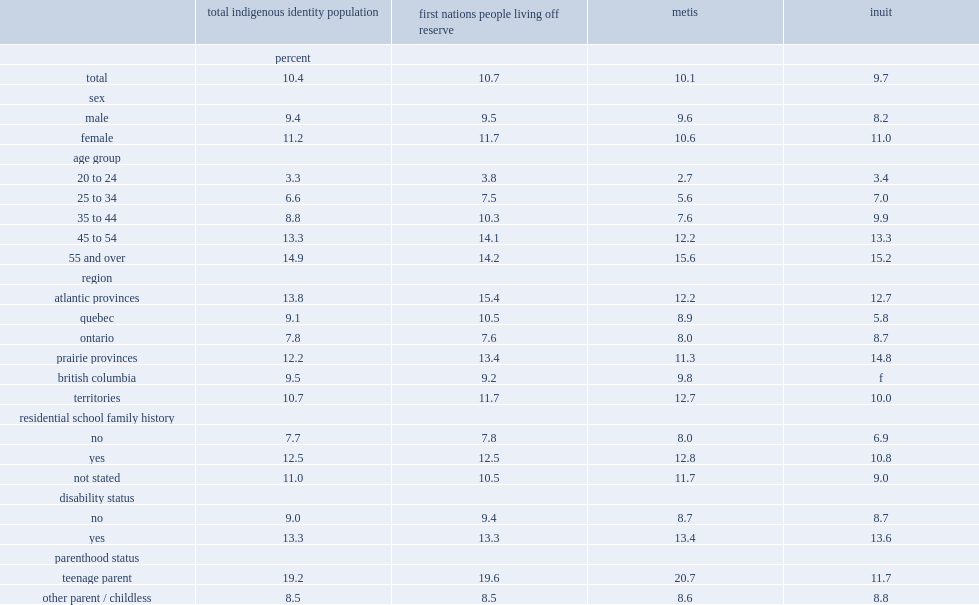How many percent of indigenous adults aged 20 to 24 reported completing an upgrading or high school equivalency program? 3.3. How many percent of indigenous adults aged 45 to 54 reported completing an upgrading or high school equivalency program? 13.3. How many percent of indigenous adults aged 55 and over reported completing an upgrading or high school equivalency program? 14.9. What was the percentages of indigenous adults living off reserve had completed an upgrading or high school equivalency program in the atlantic provinces? 13.8. What was the percentages of indigenous adults living off reserve had completed an upgrading or high school equivalency program in the prairies? 12.2. What was the percentages of indigenous adults living off reserve had completed an upgrading or high school equivalency program in the territories? 10.7. What was the percentages of indigenous adults living off reserve had completed an upgrading or high school equivalency program in the british columbia? 9.5. 